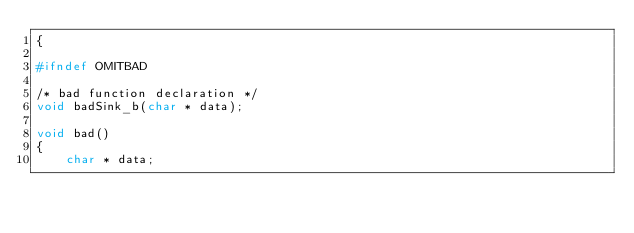<code> <loc_0><loc_0><loc_500><loc_500><_C++_>{

#ifndef OMITBAD

/* bad function declaration */
void badSink_b(char * data);

void bad()
{
    char * data;</code> 